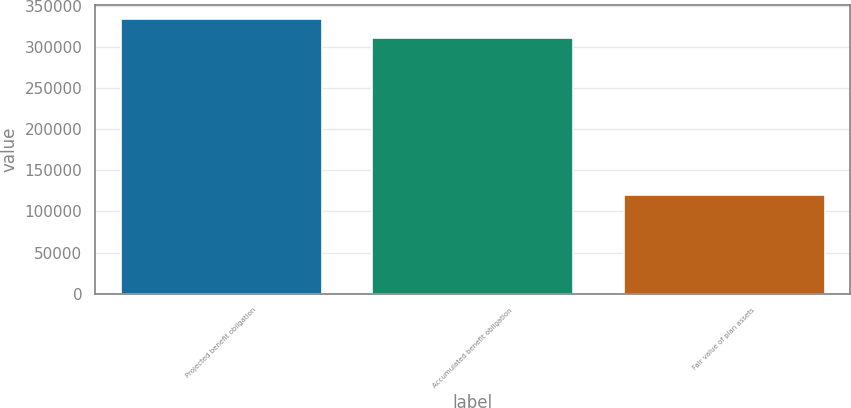<chart> <loc_0><loc_0><loc_500><loc_500><bar_chart><fcel>Projected benefit obligation<fcel>Accumulated benefit obligation<fcel>Fair value of plan assets<nl><fcel>333994<fcel>311300<fcel>120069<nl></chart> 